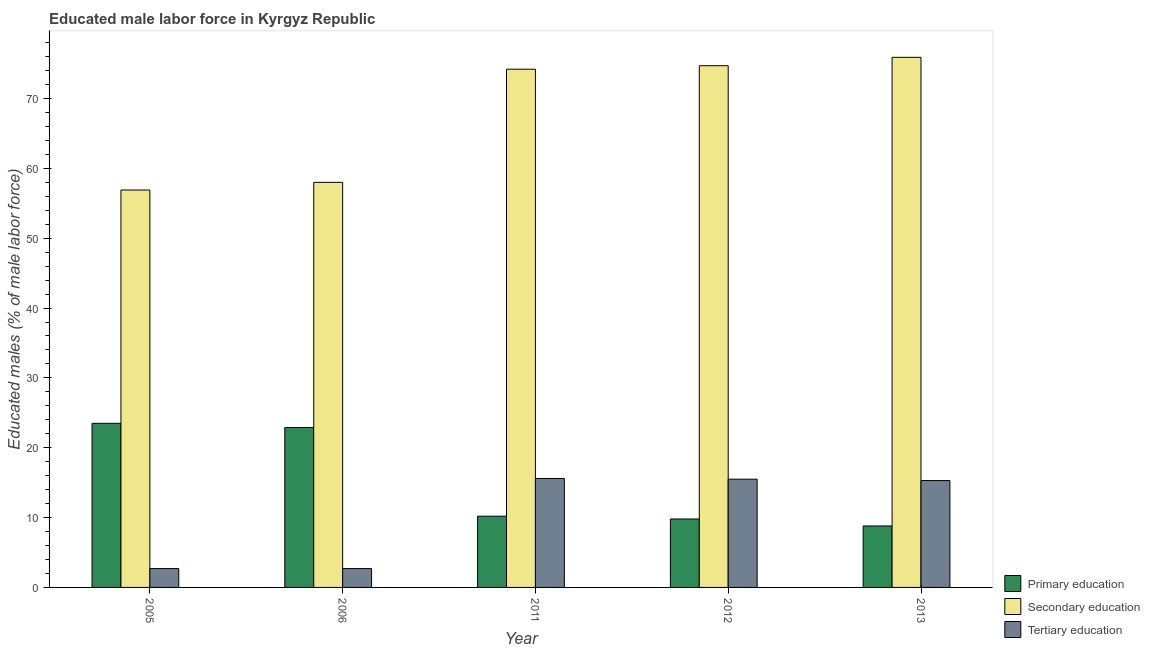What is the label of the 5th group of bars from the left?
Ensure brevity in your answer.  2013. What is the percentage of male labor force who received tertiary education in 2011?
Keep it short and to the point. 15.6. Across all years, what is the maximum percentage of male labor force who received secondary education?
Ensure brevity in your answer.  75.9. Across all years, what is the minimum percentage of male labor force who received primary education?
Keep it short and to the point. 8.8. What is the total percentage of male labor force who received secondary education in the graph?
Your answer should be compact. 339.7. What is the difference between the percentage of male labor force who received primary education in 2005 and that in 2012?
Your answer should be compact. 13.7. What is the difference between the percentage of male labor force who received tertiary education in 2013 and the percentage of male labor force who received primary education in 2006?
Offer a very short reply. 12.6. What is the average percentage of male labor force who received tertiary education per year?
Provide a short and direct response. 10.36. What is the ratio of the percentage of male labor force who received primary education in 2006 to that in 2011?
Offer a very short reply. 2.25. Is the percentage of male labor force who received tertiary education in 2005 less than that in 2006?
Give a very brief answer. No. Is the difference between the percentage of male labor force who received secondary education in 2006 and 2012 greater than the difference between the percentage of male labor force who received primary education in 2006 and 2012?
Your answer should be compact. No. What is the difference between the highest and the second highest percentage of male labor force who received secondary education?
Your answer should be very brief. 1.2. What is the difference between the highest and the lowest percentage of male labor force who received primary education?
Make the answer very short. 14.7. What does the 3rd bar from the left in 2006 represents?
Ensure brevity in your answer.  Tertiary education. What does the 1st bar from the right in 2013 represents?
Ensure brevity in your answer.  Tertiary education. How many years are there in the graph?
Make the answer very short. 5. Are the values on the major ticks of Y-axis written in scientific E-notation?
Give a very brief answer. No. Does the graph contain grids?
Offer a very short reply. No. What is the title of the graph?
Your answer should be very brief. Educated male labor force in Kyrgyz Republic. What is the label or title of the X-axis?
Your response must be concise. Year. What is the label or title of the Y-axis?
Ensure brevity in your answer.  Educated males (% of male labor force). What is the Educated males (% of male labor force) of Primary education in 2005?
Your answer should be very brief. 23.5. What is the Educated males (% of male labor force) of Secondary education in 2005?
Give a very brief answer. 56.9. What is the Educated males (% of male labor force) in Tertiary education in 2005?
Your answer should be very brief. 2.7. What is the Educated males (% of male labor force) of Primary education in 2006?
Provide a short and direct response. 22.9. What is the Educated males (% of male labor force) in Secondary education in 2006?
Ensure brevity in your answer.  58. What is the Educated males (% of male labor force) of Tertiary education in 2006?
Offer a terse response. 2.7. What is the Educated males (% of male labor force) of Primary education in 2011?
Your answer should be very brief. 10.2. What is the Educated males (% of male labor force) in Secondary education in 2011?
Your response must be concise. 74.2. What is the Educated males (% of male labor force) in Tertiary education in 2011?
Keep it short and to the point. 15.6. What is the Educated males (% of male labor force) in Primary education in 2012?
Your answer should be compact. 9.8. What is the Educated males (% of male labor force) in Secondary education in 2012?
Make the answer very short. 74.7. What is the Educated males (% of male labor force) of Tertiary education in 2012?
Make the answer very short. 15.5. What is the Educated males (% of male labor force) of Primary education in 2013?
Keep it short and to the point. 8.8. What is the Educated males (% of male labor force) in Secondary education in 2013?
Make the answer very short. 75.9. What is the Educated males (% of male labor force) of Tertiary education in 2013?
Your answer should be compact. 15.3. Across all years, what is the maximum Educated males (% of male labor force) in Secondary education?
Offer a terse response. 75.9. Across all years, what is the maximum Educated males (% of male labor force) in Tertiary education?
Provide a short and direct response. 15.6. Across all years, what is the minimum Educated males (% of male labor force) of Primary education?
Your answer should be compact. 8.8. Across all years, what is the minimum Educated males (% of male labor force) of Secondary education?
Your answer should be compact. 56.9. Across all years, what is the minimum Educated males (% of male labor force) in Tertiary education?
Give a very brief answer. 2.7. What is the total Educated males (% of male labor force) in Primary education in the graph?
Ensure brevity in your answer.  75.2. What is the total Educated males (% of male labor force) of Secondary education in the graph?
Offer a terse response. 339.7. What is the total Educated males (% of male labor force) of Tertiary education in the graph?
Offer a terse response. 51.8. What is the difference between the Educated males (% of male labor force) in Primary education in 2005 and that in 2006?
Keep it short and to the point. 0.6. What is the difference between the Educated males (% of male labor force) in Tertiary education in 2005 and that in 2006?
Give a very brief answer. 0. What is the difference between the Educated males (% of male labor force) of Secondary education in 2005 and that in 2011?
Make the answer very short. -17.3. What is the difference between the Educated males (% of male labor force) of Tertiary education in 2005 and that in 2011?
Make the answer very short. -12.9. What is the difference between the Educated males (% of male labor force) in Primary education in 2005 and that in 2012?
Ensure brevity in your answer.  13.7. What is the difference between the Educated males (% of male labor force) in Secondary education in 2005 and that in 2012?
Your response must be concise. -17.8. What is the difference between the Educated males (% of male labor force) in Tertiary education in 2005 and that in 2012?
Make the answer very short. -12.8. What is the difference between the Educated males (% of male labor force) of Secondary education in 2005 and that in 2013?
Make the answer very short. -19. What is the difference between the Educated males (% of male labor force) of Secondary education in 2006 and that in 2011?
Keep it short and to the point. -16.2. What is the difference between the Educated males (% of male labor force) of Secondary education in 2006 and that in 2012?
Offer a very short reply. -16.7. What is the difference between the Educated males (% of male labor force) of Secondary education in 2006 and that in 2013?
Provide a succinct answer. -17.9. What is the difference between the Educated males (% of male labor force) in Tertiary education in 2006 and that in 2013?
Your response must be concise. -12.6. What is the difference between the Educated males (% of male labor force) in Primary education in 2011 and that in 2012?
Your answer should be very brief. 0.4. What is the difference between the Educated males (% of male labor force) of Secondary education in 2011 and that in 2013?
Provide a succinct answer. -1.7. What is the difference between the Educated males (% of male labor force) of Tertiary education in 2011 and that in 2013?
Offer a terse response. 0.3. What is the difference between the Educated males (% of male labor force) of Primary education in 2012 and that in 2013?
Your answer should be compact. 1. What is the difference between the Educated males (% of male labor force) of Secondary education in 2012 and that in 2013?
Offer a terse response. -1.2. What is the difference between the Educated males (% of male labor force) in Tertiary education in 2012 and that in 2013?
Provide a short and direct response. 0.2. What is the difference between the Educated males (% of male labor force) in Primary education in 2005 and the Educated males (% of male labor force) in Secondary education in 2006?
Provide a succinct answer. -34.5. What is the difference between the Educated males (% of male labor force) of Primary education in 2005 and the Educated males (% of male labor force) of Tertiary education in 2006?
Give a very brief answer. 20.8. What is the difference between the Educated males (% of male labor force) in Secondary education in 2005 and the Educated males (% of male labor force) in Tertiary education in 2006?
Offer a terse response. 54.2. What is the difference between the Educated males (% of male labor force) of Primary education in 2005 and the Educated males (% of male labor force) of Secondary education in 2011?
Your answer should be compact. -50.7. What is the difference between the Educated males (% of male labor force) of Primary education in 2005 and the Educated males (% of male labor force) of Tertiary education in 2011?
Your answer should be very brief. 7.9. What is the difference between the Educated males (% of male labor force) of Secondary education in 2005 and the Educated males (% of male labor force) of Tertiary education in 2011?
Your answer should be very brief. 41.3. What is the difference between the Educated males (% of male labor force) in Primary education in 2005 and the Educated males (% of male labor force) in Secondary education in 2012?
Offer a very short reply. -51.2. What is the difference between the Educated males (% of male labor force) of Secondary education in 2005 and the Educated males (% of male labor force) of Tertiary education in 2012?
Ensure brevity in your answer.  41.4. What is the difference between the Educated males (% of male labor force) in Primary education in 2005 and the Educated males (% of male labor force) in Secondary education in 2013?
Offer a very short reply. -52.4. What is the difference between the Educated males (% of male labor force) of Secondary education in 2005 and the Educated males (% of male labor force) of Tertiary education in 2013?
Provide a succinct answer. 41.6. What is the difference between the Educated males (% of male labor force) of Primary education in 2006 and the Educated males (% of male labor force) of Secondary education in 2011?
Make the answer very short. -51.3. What is the difference between the Educated males (% of male labor force) in Primary education in 2006 and the Educated males (% of male labor force) in Tertiary education in 2011?
Make the answer very short. 7.3. What is the difference between the Educated males (% of male labor force) in Secondary education in 2006 and the Educated males (% of male labor force) in Tertiary education in 2011?
Ensure brevity in your answer.  42.4. What is the difference between the Educated males (% of male labor force) of Primary education in 2006 and the Educated males (% of male labor force) of Secondary education in 2012?
Your answer should be compact. -51.8. What is the difference between the Educated males (% of male labor force) of Secondary education in 2006 and the Educated males (% of male labor force) of Tertiary education in 2012?
Give a very brief answer. 42.5. What is the difference between the Educated males (% of male labor force) of Primary education in 2006 and the Educated males (% of male labor force) of Secondary education in 2013?
Your answer should be compact. -53. What is the difference between the Educated males (% of male labor force) of Secondary education in 2006 and the Educated males (% of male labor force) of Tertiary education in 2013?
Your answer should be very brief. 42.7. What is the difference between the Educated males (% of male labor force) of Primary education in 2011 and the Educated males (% of male labor force) of Secondary education in 2012?
Your answer should be very brief. -64.5. What is the difference between the Educated males (% of male labor force) of Primary education in 2011 and the Educated males (% of male labor force) of Tertiary education in 2012?
Offer a very short reply. -5.3. What is the difference between the Educated males (% of male labor force) in Secondary education in 2011 and the Educated males (% of male labor force) in Tertiary education in 2012?
Offer a very short reply. 58.7. What is the difference between the Educated males (% of male labor force) in Primary education in 2011 and the Educated males (% of male labor force) in Secondary education in 2013?
Make the answer very short. -65.7. What is the difference between the Educated males (% of male labor force) of Secondary education in 2011 and the Educated males (% of male labor force) of Tertiary education in 2013?
Offer a terse response. 58.9. What is the difference between the Educated males (% of male labor force) of Primary education in 2012 and the Educated males (% of male labor force) of Secondary education in 2013?
Provide a succinct answer. -66.1. What is the difference between the Educated males (% of male labor force) in Secondary education in 2012 and the Educated males (% of male labor force) in Tertiary education in 2013?
Give a very brief answer. 59.4. What is the average Educated males (% of male labor force) in Primary education per year?
Make the answer very short. 15.04. What is the average Educated males (% of male labor force) of Secondary education per year?
Provide a succinct answer. 67.94. What is the average Educated males (% of male labor force) of Tertiary education per year?
Keep it short and to the point. 10.36. In the year 2005, what is the difference between the Educated males (% of male labor force) of Primary education and Educated males (% of male labor force) of Secondary education?
Offer a terse response. -33.4. In the year 2005, what is the difference between the Educated males (% of male labor force) in Primary education and Educated males (% of male labor force) in Tertiary education?
Provide a succinct answer. 20.8. In the year 2005, what is the difference between the Educated males (% of male labor force) of Secondary education and Educated males (% of male labor force) of Tertiary education?
Provide a succinct answer. 54.2. In the year 2006, what is the difference between the Educated males (% of male labor force) of Primary education and Educated males (% of male labor force) of Secondary education?
Provide a short and direct response. -35.1. In the year 2006, what is the difference between the Educated males (% of male labor force) of Primary education and Educated males (% of male labor force) of Tertiary education?
Offer a very short reply. 20.2. In the year 2006, what is the difference between the Educated males (% of male labor force) of Secondary education and Educated males (% of male labor force) of Tertiary education?
Offer a terse response. 55.3. In the year 2011, what is the difference between the Educated males (% of male labor force) of Primary education and Educated males (% of male labor force) of Secondary education?
Provide a short and direct response. -64. In the year 2011, what is the difference between the Educated males (% of male labor force) of Primary education and Educated males (% of male labor force) of Tertiary education?
Offer a very short reply. -5.4. In the year 2011, what is the difference between the Educated males (% of male labor force) in Secondary education and Educated males (% of male labor force) in Tertiary education?
Your response must be concise. 58.6. In the year 2012, what is the difference between the Educated males (% of male labor force) in Primary education and Educated males (% of male labor force) in Secondary education?
Ensure brevity in your answer.  -64.9. In the year 2012, what is the difference between the Educated males (% of male labor force) of Primary education and Educated males (% of male labor force) of Tertiary education?
Ensure brevity in your answer.  -5.7. In the year 2012, what is the difference between the Educated males (% of male labor force) in Secondary education and Educated males (% of male labor force) in Tertiary education?
Ensure brevity in your answer.  59.2. In the year 2013, what is the difference between the Educated males (% of male labor force) in Primary education and Educated males (% of male labor force) in Secondary education?
Provide a succinct answer. -67.1. In the year 2013, what is the difference between the Educated males (% of male labor force) in Secondary education and Educated males (% of male labor force) in Tertiary education?
Offer a very short reply. 60.6. What is the ratio of the Educated males (% of male labor force) of Primary education in 2005 to that in 2006?
Ensure brevity in your answer.  1.03. What is the ratio of the Educated males (% of male labor force) in Tertiary education in 2005 to that in 2006?
Provide a succinct answer. 1. What is the ratio of the Educated males (% of male labor force) of Primary education in 2005 to that in 2011?
Offer a terse response. 2.3. What is the ratio of the Educated males (% of male labor force) of Secondary education in 2005 to that in 2011?
Offer a terse response. 0.77. What is the ratio of the Educated males (% of male labor force) of Tertiary education in 2005 to that in 2011?
Make the answer very short. 0.17. What is the ratio of the Educated males (% of male labor force) of Primary education in 2005 to that in 2012?
Make the answer very short. 2.4. What is the ratio of the Educated males (% of male labor force) of Secondary education in 2005 to that in 2012?
Offer a very short reply. 0.76. What is the ratio of the Educated males (% of male labor force) of Tertiary education in 2005 to that in 2012?
Your response must be concise. 0.17. What is the ratio of the Educated males (% of male labor force) in Primary education in 2005 to that in 2013?
Offer a terse response. 2.67. What is the ratio of the Educated males (% of male labor force) in Secondary education in 2005 to that in 2013?
Your response must be concise. 0.75. What is the ratio of the Educated males (% of male labor force) of Tertiary education in 2005 to that in 2013?
Ensure brevity in your answer.  0.18. What is the ratio of the Educated males (% of male labor force) of Primary education in 2006 to that in 2011?
Provide a short and direct response. 2.25. What is the ratio of the Educated males (% of male labor force) in Secondary education in 2006 to that in 2011?
Make the answer very short. 0.78. What is the ratio of the Educated males (% of male labor force) of Tertiary education in 2006 to that in 2011?
Ensure brevity in your answer.  0.17. What is the ratio of the Educated males (% of male labor force) of Primary education in 2006 to that in 2012?
Your answer should be very brief. 2.34. What is the ratio of the Educated males (% of male labor force) of Secondary education in 2006 to that in 2012?
Ensure brevity in your answer.  0.78. What is the ratio of the Educated males (% of male labor force) in Tertiary education in 2006 to that in 2012?
Your answer should be very brief. 0.17. What is the ratio of the Educated males (% of male labor force) of Primary education in 2006 to that in 2013?
Make the answer very short. 2.6. What is the ratio of the Educated males (% of male labor force) of Secondary education in 2006 to that in 2013?
Your response must be concise. 0.76. What is the ratio of the Educated males (% of male labor force) of Tertiary education in 2006 to that in 2013?
Provide a succinct answer. 0.18. What is the ratio of the Educated males (% of male labor force) of Primary education in 2011 to that in 2012?
Provide a succinct answer. 1.04. What is the ratio of the Educated males (% of male labor force) of Secondary education in 2011 to that in 2012?
Your answer should be very brief. 0.99. What is the ratio of the Educated males (% of male labor force) in Tertiary education in 2011 to that in 2012?
Your answer should be very brief. 1.01. What is the ratio of the Educated males (% of male labor force) in Primary education in 2011 to that in 2013?
Provide a succinct answer. 1.16. What is the ratio of the Educated males (% of male labor force) of Secondary education in 2011 to that in 2013?
Provide a succinct answer. 0.98. What is the ratio of the Educated males (% of male labor force) of Tertiary education in 2011 to that in 2013?
Provide a short and direct response. 1.02. What is the ratio of the Educated males (% of male labor force) of Primary education in 2012 to that in 2013?
Give a very brief answer. 1.11. What is the ratio of the Educated males (% of male labor force) of Secondary education in 2012 to that in 2013?
Your response must be concise. 0.98. What is the ratio of the Educated males (% of male labor force) in Tertiary education in 2012 to that in 2013?
Offer a terse response. 1.01. What is the difference between the highest and the second highest Educated males (% of male labor force) of Tertiary education?
Give a very brief answer. 0.1. 